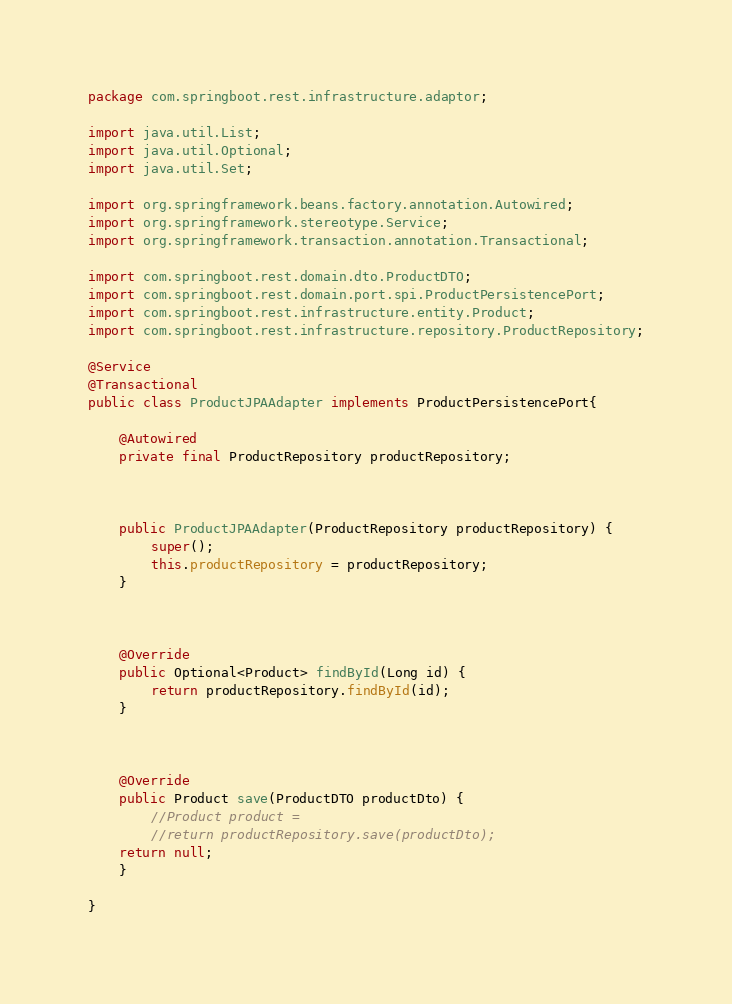<code> <loc_0><loc_0><loc_500><loc_500><_Java_>package com.springboot.rest.infrastructure.adaptor;

import java.util.List;
import java.util.Optional;
import java.util.Set;

import org.springframework.beans.factory.annotation.Autowired;
import org.springframework.stereotype.Service;
import org.springframework.transaction.annotation.Transactional;

import com.springboot.rest.domain.dto.ProductDTO;
import com.springboot.rest.domain.port.spi.ProductPersistencePort;
import com.springboot.rest.infrastructure.entity.Product;
import com.springboot.rest.infrastructure.repository.ProductRepository;

@Service
@Transactional
public class ProductJPAAdapter implements ProductPersistencePort{

	@Autowired
	private final ProductRepository productRepository;
	
	
	
	public ProductJPAAdapter(ProductRepository productRepository) {
		super();
		this.productRepository = productRepository;
	}



	@Override
	public Optional<Product> findById(Long id) {
		return productRepository.findById(id);
	}



	@Override
	public Product save(ProductDTO productDto) {
		//Product product = 
		//return productRepository.save(productDto);
	return null;
	}

}
</code> 